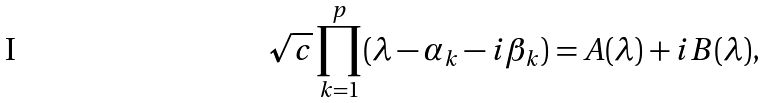Convert formula to latex. <formula><loc_0><loc_0><loc_500><loc_500>\sqrt { c } \prod _ { k = 1 } ^ { p } ( \lambda - \alpha _ { k } - i \beta _ { k } ) = A ( \lambda ) + i B ( \lambda ) ,</formula> 